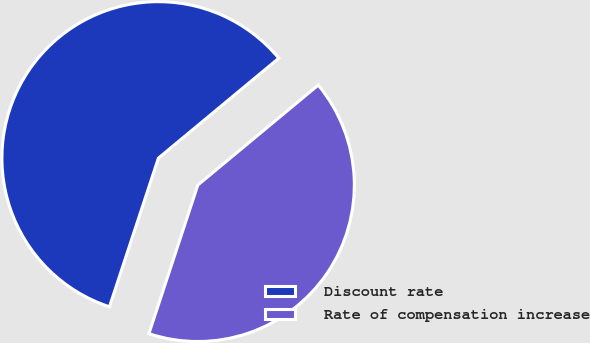Convert chart to OTSL. <chart><loc_0><loc_0><loc_500><loc_500><pie_chart><fcel>Discount rate<fcel>Rate of compensation increase<nl><fcel>58.91%<fcel>41.09%<nl></chart> 